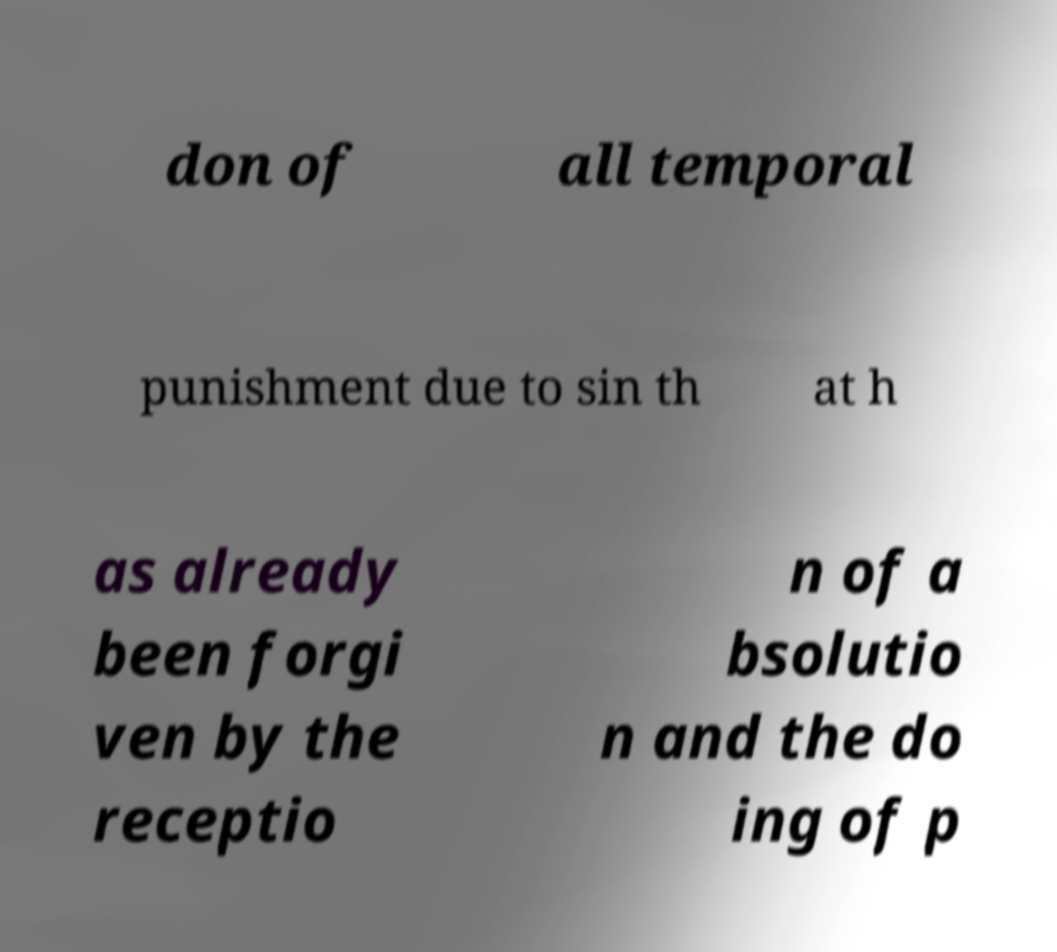Could you assist in decoding the text presented in this image and type it out clearly? don of all temporal punishment due to sin th at h as already been forgi ven by the receptio n of a bsolutio n and the do ing of p 